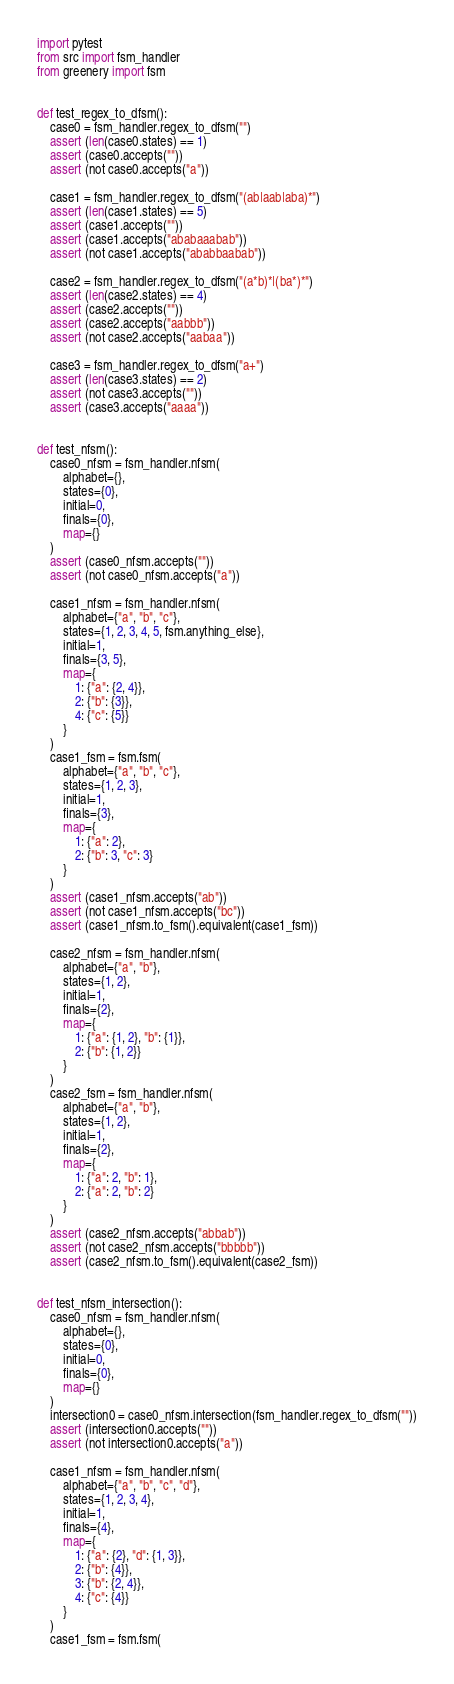<code> <loc_0><loc_0><loc_500><loc_500><_Python_>import pytest
from src import fsm_handler
from greenery import fsm


def test_regex_to_dfsm():
    case0 = fsm_handler.regex_to_dfsm("")
    assert (len(case0.states) == 1)
    assert (case0.accepts(""))
    assert (not case0.accepts("a"))

    case1 = fsm_handler.regex_to_dfsm("(ab|aab|aba)*")
    assert (len(case1.states) == 5)
    assert (case1.accepts(""))
    assert (case1.accepts("ababaaabab"))
    assert (not case1.accepts("ababbaabab"))

    case2 = fsm_handler.regex_to_dfsm("(a*b)*|(ba*)*")
    assert (len(case2.states) == 4)
    assert (case2.accepts(""))
    assert (case2.accepts("aabbb"))
    assert (not case2.accepts("aabaa"))

    case3 = fsm_handler.regex_to_dfsm("a+")
    assert (len(case3.states) == 2)
    assert (not case3.accepts(""))
    assert (case3.accepts("aaaa"))


def test_nfsm():
    case0_nfsm = fsm_handler.nfsm(
        alphabet={},
        states={0},
        initial=0,
        finals={0},
        map={}
    )
    assert (case0_nfsm.accepts(""))
    assert (not case0_nfsm.accepts("a"))

    case1_nfsm = fsm_handler.nfsm(
        alphabet={"a", "b", "c"},
        states={1, 2, 3, 4, 5, fsm.anything_else},
        initial=1,
        finals={3, 5},
        map={
            1: {"a": {2, 4}},
            2: {"b": {3}},
            4: {"c": {5}}
        }
    )
    case1_fsm = fsm.fsm(
        alphabet={"a", "b", "c"},
        states={1, 2, 3},
        initial=1,
        finals={3},
        map={
            1: {"a": 2},
            2: {"b": 3, "c": 3}
        }
    )
    assert (case1_nfsm.accepts("ab"))
    assert (not case1_nfsm.accepts("bc"))
    assert (case1_nfsm.to_fsm().equivalent(case1_fsm))

    case2_nfsm = fsm_handler.nfsm(
        alphabet={"a", "b"},
        states={1, 2},
        initial=1,
        finals={2},
        map={
            1: {"a": {1, 2}, "b": {1}},
            2: {"b": {1, 2}}
        }
    )
    case2_fsm = fsm_handler.nfsm(
        alphabet={"a", "b"},
        states={1, 2},
        initial=1,
        finals={2},
        map={
            1: {"a": 2, "b": 1},
            2: {"a": 2, "b": 2}
        }
    )
    assert (case2_nfsm.accepts("abbab"))
    assert (not case2_nfsm.accepts("bbbbb"))
    assert (case2_nfsm.to_fsm().equivalent(case2_fsm))


def test_nfsm_intersection():
    case0_nfsm = fsm_handler.nfsm(
        alphabet={},
        states={0},
        initial=0,
        finals={0},
        map={}
    )
    intersection0 = case0_nfsm.intersection(fsm_handler.regex_to_dfsm(""))
    assert (intersection0.accepts(""))
    assert (not intersection0.accepts("a"))

    case1_nfsm = fsm_handler.nfsm(
        alphabet={"a", "b", "c", "d"},
        states={1, 2, 3, 4},
        initial=1,
        finals={4},
        map={
            1: {"a": {2}, "d": {1, 3}},
            2: {"b": {4}},
            3: {"b": {2, 4}},
            4: {"c": {4}}
        }
    )
    case1_fsm = fsm.fsm(</code> 